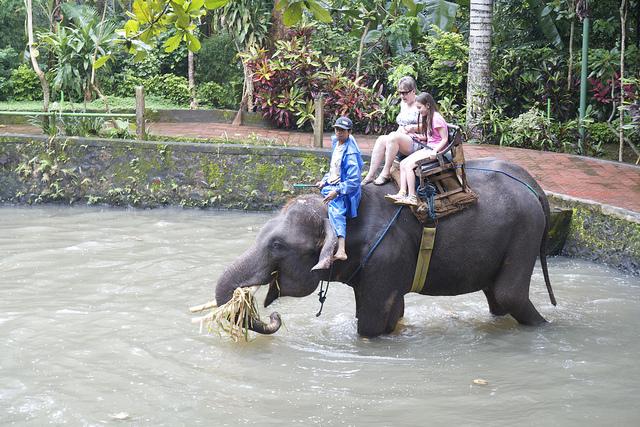How many people are riding this elephant?
Short answer required. 3. Is the elephant swimming?
Give a very brief answer. No. What is the elephant going to eat?
Answer briefly. Grass. Is this during the day?
Answer briefly. Yes. 